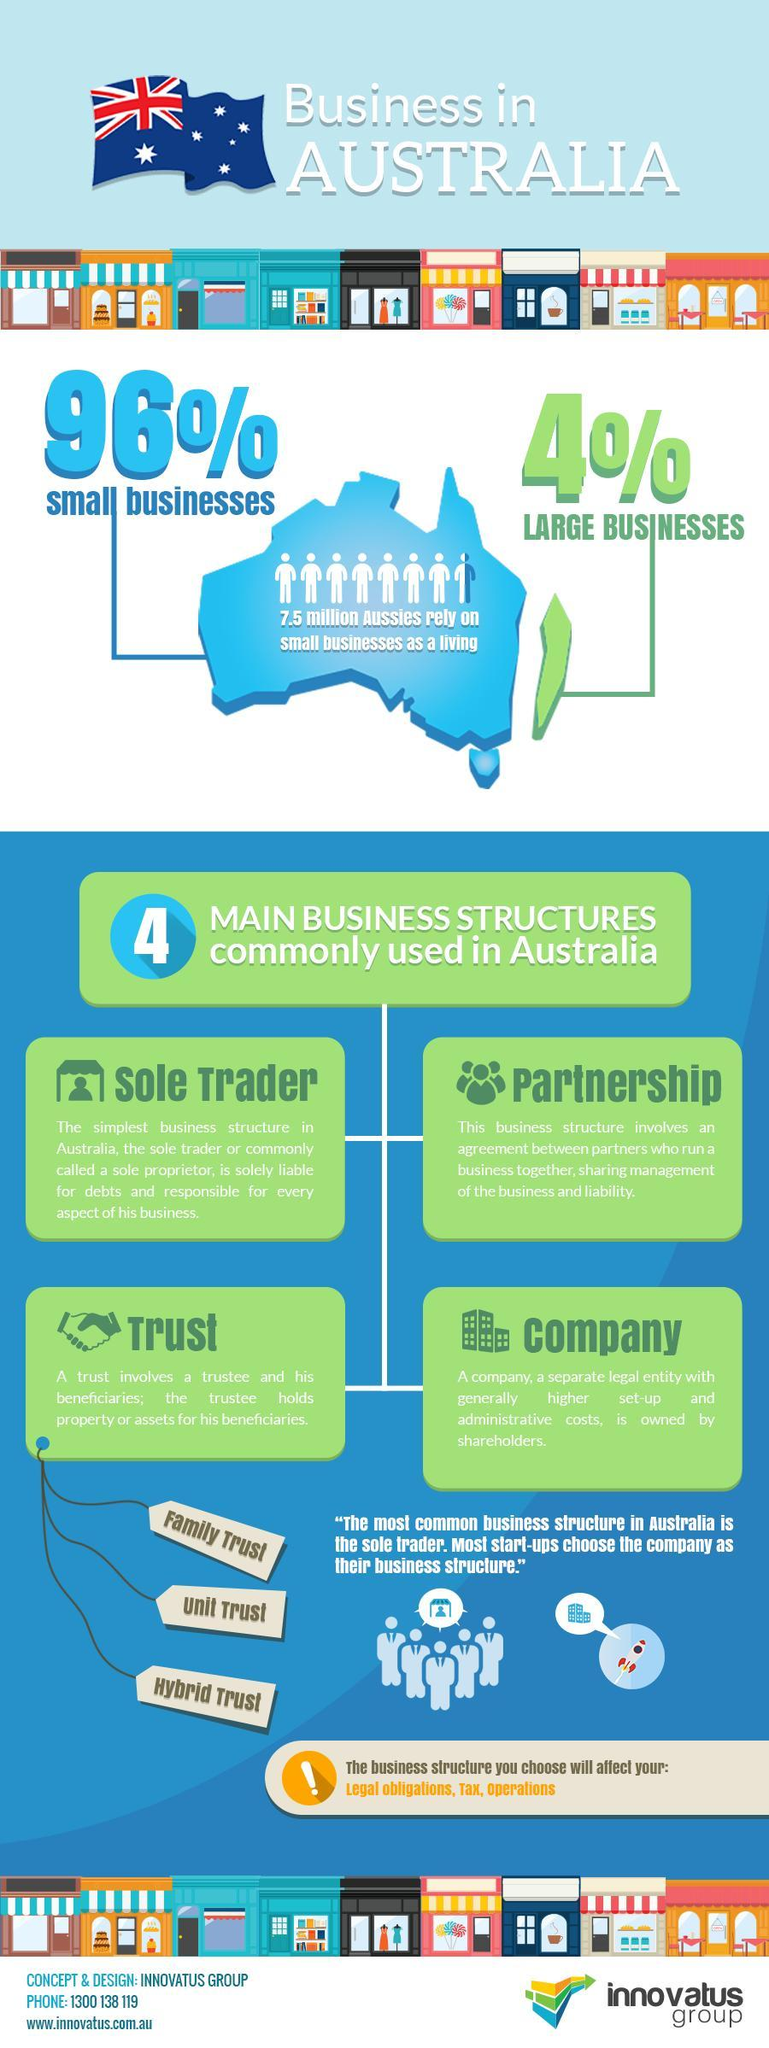What kind of businesses least dominate in the Australian economy?
Answer the question with a short phrase. Large Businesses What kind of businesses largely dominate in the Australian economy? Small Businesses What population rate of Aussies rely on Small Businesses for a living? 7.5 Million How many business structures are commonly used in Australia? Four 